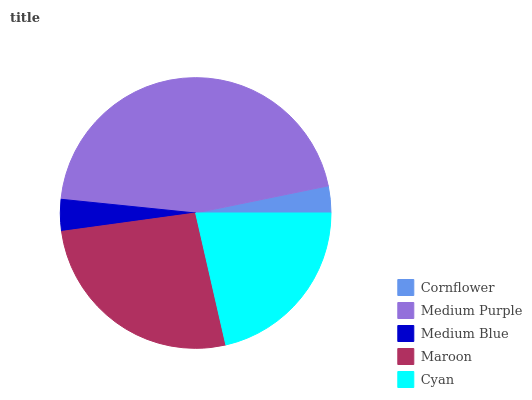Is Cornflower the minimum?
Answer yes or no. Yes. Is Medium Purple the maximum?
Answer yes or no. Yes. Is Medium Blue the minimum?
Answer yes or no. No. Is Medium Blue the maximum?
Answer yes or no. No. Is Medium Purple greater than Medium Blue?
Answer yes or no. Yes. Is Medium Blue less than Medium Purple?
Answer yes or no. Yes. Is Medium Blue greater than Medium Purple?
Answer yes or no. No. Is Medium Purple less than Medium Blue?
Answer yes or no. No. Is Cyan the high median?
Answer yes or no. Yes. Is Cyan the low median?
Answer yes or no. Yes. Is Maroon the high median?
Answer yes or no. No. Is Medium Blue the low median?
Answer yes or no. No. 